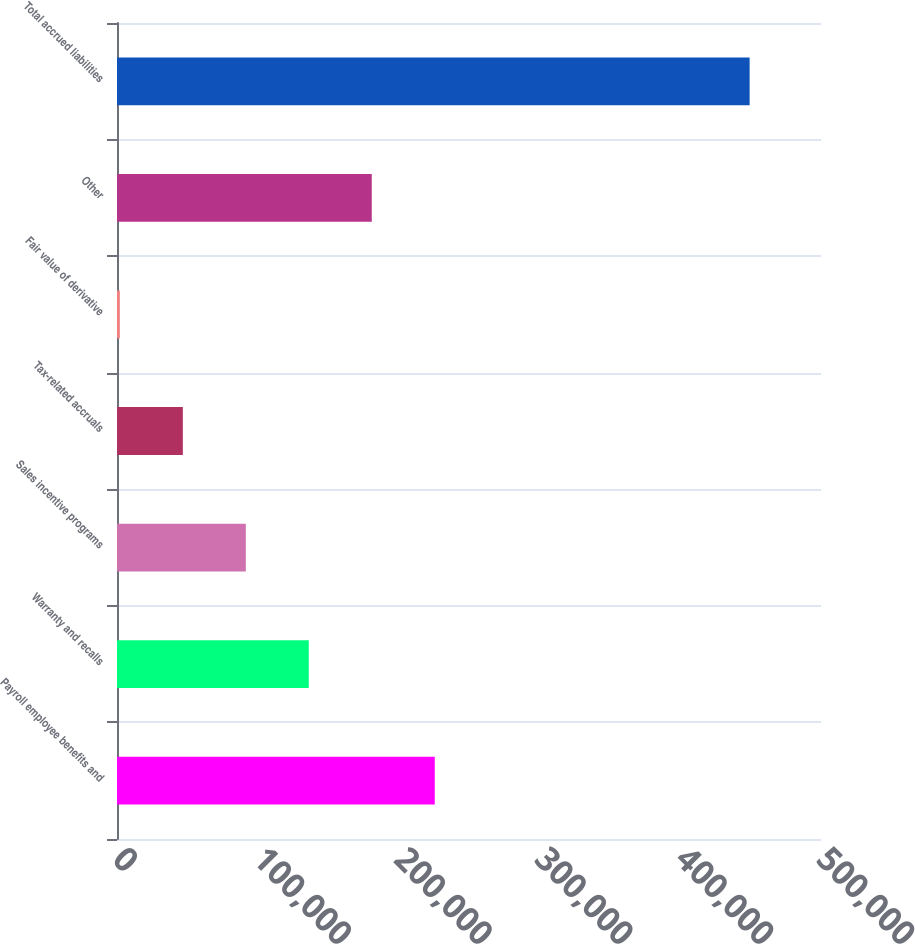Convert chart. <chart><loc_0><loc_0><loc_500><loc_500><bar_chart><fcel>Payroll employee benefits and<fcel>Warranty and recalls<fcel>Sales incentive programs<fcel>Tax-related accruals<fcel>Fair value of derivative<fcel>Other<fcel>Total accrued liabilities<nl><fcel>225672<fcel>136214<fcel>91485<fcel>46756<fcel>2027<fcel>180943<fcel>449317<nl></chart> 